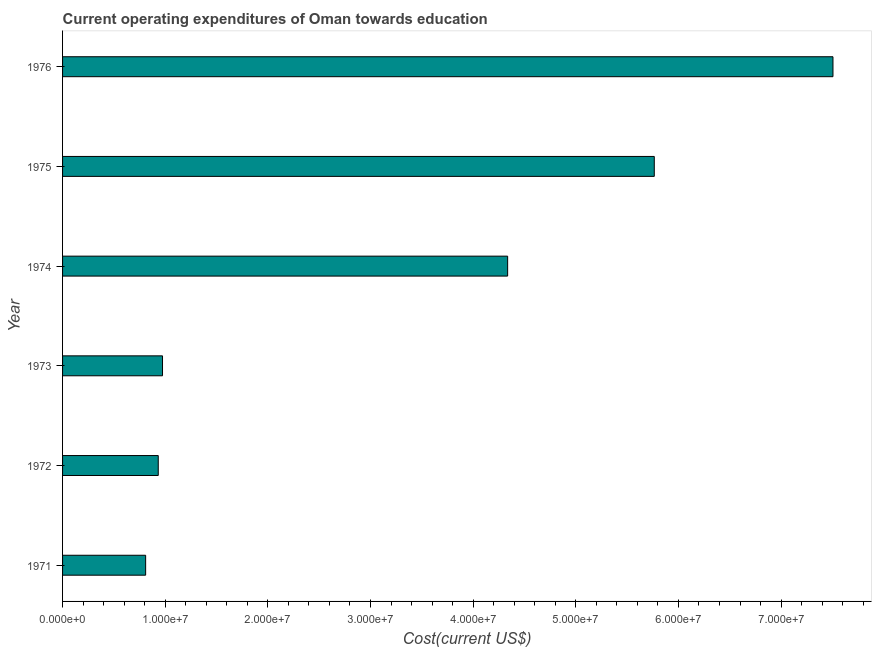Does the graph contain any zero values?
Provide a succinct answer. No. Does the graph contain grids?
Offer a very short reply. No. What is the title of the graph?
Keep it short and to the point. Current operating expenditures of Oman towards education. What is the label or title of the X-axis?
Give a very brief answer. Cost(current US$). What is the education expenditure in 1976?
Your response must be concise. 7.51e+07. Across all years, what is the maximum education expenditure?
Provide a short and direct response. 7.51e+07. Across all years, what is the minimum education expenditure?
Give a very brief answer. 8.09e+06. In which year was the education expenditure maximum?
Give a very brief answer. 1976. What is the sum of the education expenditure?
Your response must be concise. 2.03e+08. What is the difference between the education expenditure in 1972 and 1975?
Make the answer very short. -4.83e+07. What is the average education expenditure per year?
Ensure brevity in your answer.  3.39e+07. What is the median education expenditure?
Ensure brevity in your answer.  2.65e+07. In how many years, is the education expenditure greater than 76000000 US$?
Offer a very short reply. 0. Do a majority of the years between 1975 and 1972 (inclusive) have education expenditure greater than 70000000 US$?
Offer a terse response. Yes. What is the ratio of the education expenditure in 1973 to that in 1974?
Offer a terse response. 0.23. What is the difference between the highest and the second highest education expenditure?
Your response must be concise. 1.74e+07. What is the difference between the highest and the lowest education expenditure?
Your answer should be very brief. 6.70e+07. In how many years, is the education expenditure greater than the average education expenditure taken over all years?
Keep it short and to the point. 3. What is the Cost(current US$) in 1971?
Your answer should be very brief. 8.09e+06. What is the Cost(current US$) in 1972?
Provide a succinct answer. 9.32e+06. What is the Cost(current US$) in 1973?
Your response must be concise. 9.74e+06. What is the Cost(current US$) in 1974?
Provide a succinct answer. 4.34e+07. What is the Cost(current US$) in 1975?
Your response must be concise. 5.76e+07. What is the Cost(current US$) of 1976?
Your answer should be very brief. 7.51e+07. What is the difference between the Cost(current US$) in 1971 and 1972?
Provide a succinct answer. -1.23e+06. What is the difference between the Cost(current US$) in 1971 and 1973?
Provide a succinct answer. -1.64e+06. What is the difference between the Cost(current US$) in 1971 and 1974?
Keep it short and to the point. -3.53e+07. What is the difference between the Cost(current US$) in 1971 and 1975?
Ensure brevity in your answer.  -4.96e+07. What is the difference between the Cost(current US$) in 1971 and 1976?
Offer a terse response. -6.70e+07. What is the difference between the Cost(current US$) in 1972 and 1973?
Your response must be concise. -4.14e+05. What is the difference between the Cost(current US$) in 1972 and 1974?
Your response must be concise. -3.40e+07. What is the difference between the Cost(current US$) in 1972 and 1975?
Provide a succinct answer. -4.83e+07. What is the difference between the Cost(current US$) in 1972 and 1976?
Give a very brief answer. -6.57e+07. What is the difference between the Cost(current US$) in 1973 and 1974?
Ensure brevity in your answer.  -3.36e+07. What is the difference between the Cost(current US$) in 1973 and 1975?
Ensure brevity in your answer.  -4.79e+07. What is the difference between the Cost(current US$) in 1973 and 1976?
Your answer should be compact. -6.53e+07. What is the difference between the Cost(current US$) in 1974 and 1975?
Offer a terse response. -1.43e+07. What is the difference between the Cost(current US$) in 1974 and 1976?
Provide a short and direct response. -3.17e+07. What is the difference between the Cost(current US$) in 1975 and 1976?
Your answer should be compact. -1.74e+07. What is the ratio of the Cost(current US$) in 1971 to that in 1972?
Give a very brief answer. 0.87. What is the ratio of the Cost(current US$) in 1971 to that in 1973?
Ensure brevity in your answer.  0.83. What is the ratio of the Cost(current US$) in 1971 to that in 1974?
Your answer should be compact. 0.19. What is the ratio of the Cost(current US$) in 1971 to that in 1975?
Provide a succinct answer. 0.14. What is the ratio of the Cost(current US$) in 1971 to that in 1976?
Make the answer very short. 0.11. What is the ratio of the Cost(current US$) in 1972 to that in 1973?
Your answer should be compact. 0.96. What is the ratio of the Cost(current US$) in 1972 to that in 1974?
Your answer should be compact. 0.21. What is the ratio of the Cost(current US$) in 1972 to that in 1975?
Ensure brevity in your answer.  0.16. What is the ratio of the Cost(current US$) in 1972 to that in 1976?
Ensure brevity in your answer.  0.12. What is the ratio of the Cost(current US$) in 1973 to that in 1974?
Make the answer very short. 0.23. What is the ratio of the Cost(current US$) in 1973 to that in 1975?
Ensure brevity in your answer.  0.17. What is the ratio of the Cost(current US$) in 1973 to that in 1976?
Make the answer very short. 0.13. What is the ratio of the Cost(current US$) in 1974 to that in 1975?
Ensure brevity in your answer.  0.75. What is the ratio of the Cost(current US$) in 1974 to that in 1976?
Provide a succinct answer. 0.58. What is the ratio of the Cost(current US$) in 1975 to that in 1976?
Your answer should be compact. 0.77. 